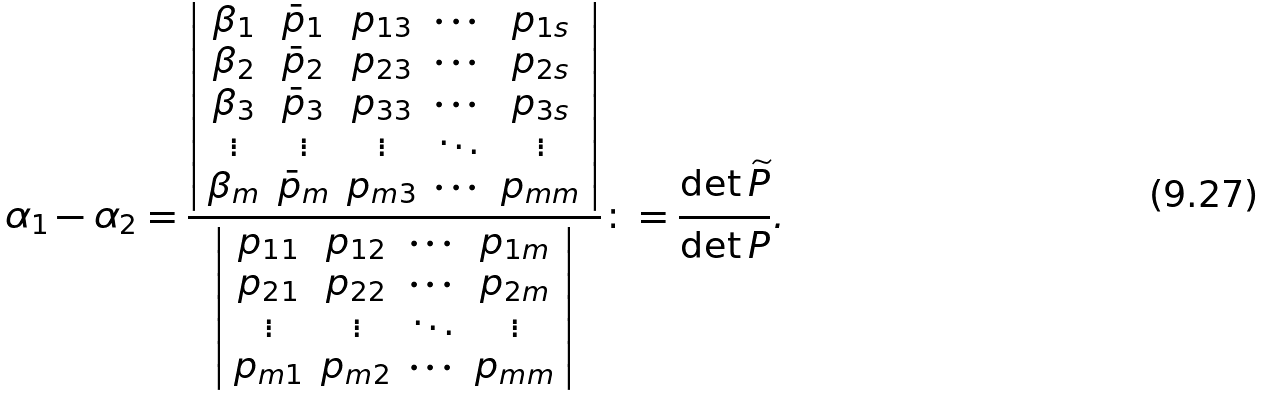Convert formula to latex. <formula><loc_0><loc_0><loc_500><loc_500>\alpha _ { 1 } - \alpha _ { 2 } = \frac { \left | \begin{array} { c c c c c } \beta _ { 1 } & \bar { p } _ { 1 } & p _ { 1 3 } & \cdots & p _ { 1 s } \\ \beta _ { 2 } & \bar { p } _ { 2 } & p _ { 2 3 } & \cdots & p _ { 2 s } \\ \beta _ { 3 } & \bar { p } _ { 3 } & p _ { 3 3 } & \cdots & p _ { 3 s } \\ \vdots & \vdots & \vdots & \ddots & \vdots \\ \beta _ { m } & \bar { p } _ { m } & p _ { m 3 } & \cdots & p _ { m m } \end{array} \right | } { \left | \begin{array} { c c c c } p _ { 1 1 } & p _ { 1 2 } & \cdots & p _ { 1 m } \\ p _ { 2 1 } & p _ { 2 2 } & \cdots & p _ { 2 m } \\ \vdots & \vdots & \ddots & \vdots \\ p _ { m 1 } & p _ { m 2 } & \cdots & p _ { m m } \end{array} \right | } \colon = \frac { \det \widetilde { P } } { \det P } .</formula> 